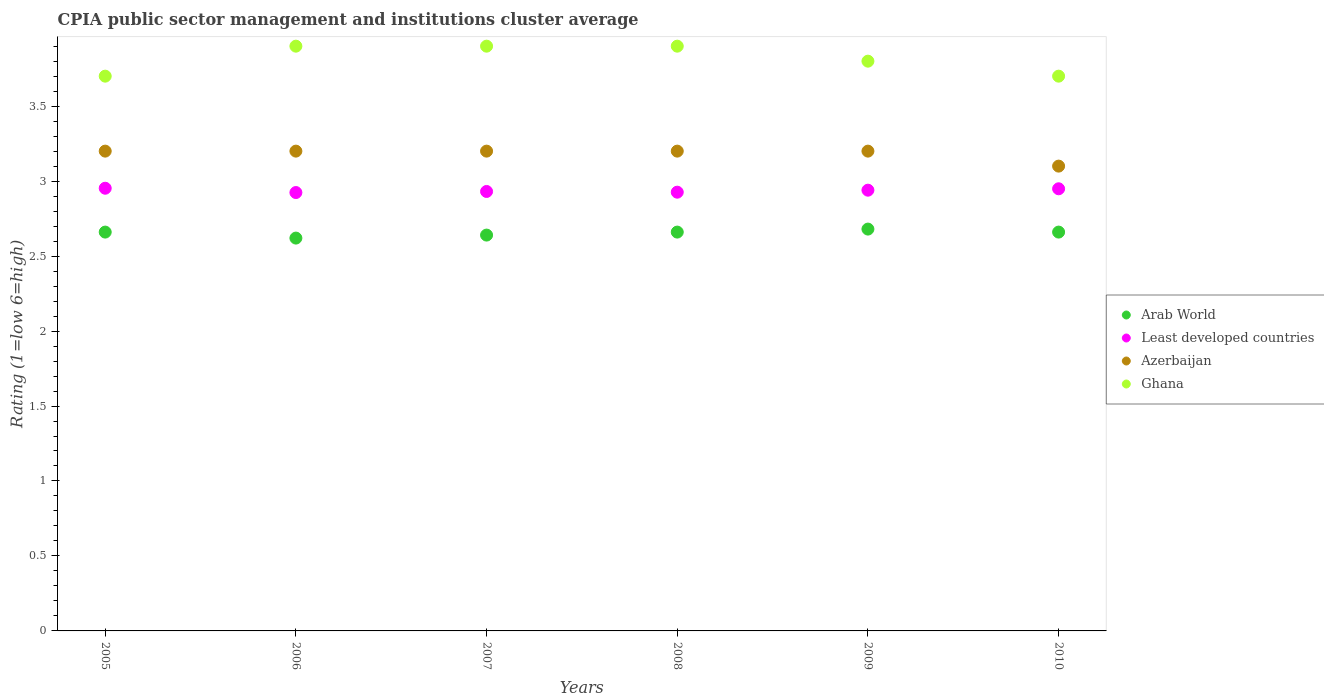How many different coloured dotlines are there?
Offer a terse response. 4. Across all years, what is the maximum CPIA rating in Azerbaijan?
Provide a short and direct response. 3.2. Across all years, what is the minimum CPIA rating in Azerbaijan?
Make the answer very short. 3.1. In which year was the CPIA rating in Least developed countries maximum?
Your answer should be very brief. 2005. In which year was the CPIA rating in Ghana minimum?
Offer a terse response. 2005. What is the difference between the CPIA rating in Least developed countries in 2005 and that in 2009?
Your answer should be compact. 0.01. What is the difference between the CPIA rating in Ghana in 2005 and the CPIA rating in Azerbaijan in 2009?
Keep it short and to the point. 0.5. What is the average CPIA rating in Arab World per year?
Your response must be concise. 2.65. In the year 2009, what is the difference between the CPIA rating in Arab World and CPIA rating in Least developed countries?
Your answer should be very brief. -0.26. What is the ratio of the CPIA rating in Arab World in 2006 to that in 2009?
Make the answer very short. 0.98. Is the difference between the CPIA rating in Arab World in 2005 and 2006 greater than the difference between the CPIA rating in Least developed countries in 2005 and 2006?
Make the answer very short. Yes. What is the difference between the highest and the second highest CPIA rating in Arab World?
Your answer should be very brief. 0.02. What is the difference between the highest and the lowest CPIA rating in Ghana?
Provide a succinct answer. 0.2. In how many years, is the CPIA rating in Arab World greater than the average CPIA rating in Arab World taken over all years?
Your answer should be very brief. 4. Is it the case that in every year, the sum of the CPIA rating in Ghana and CPIA rating in Azerbaijan  is greater than the sum of CPIA rating in Arab World and CPIA rating in Least developed countries?
Offer a very short reply. Yes. Is the CPIA rating in Least developed countries strictly greater than the CPIA rating in Arab World over the years?
Your answer should be very brief. Yes. Is the CPIA rating in Ghana strictly less than the CPIA rating in Arab World over the years?
Offer a very short reply. No. How many dotlines are there?
Provide a short and direct response. 4. How many years are there in the graph?
Give a very brief answer. 6. What is the difference between two consecutive major ticks on the Y-axis?
Offer a very short reply. 0.5. Does the graph contain any zero values?
Make the answer very short. No. Does the graph contain grids?
Provide a succinct answer. No. How many legend labels are there?
Offer a terse response. 4. How are the legend labels stacked?
Provide a short and direct response. Vertical. What is the title of the graph?
Ensure brevity in your answer.  CPIA public sector management and institutions cluster average. Does "Virgin Islands" appear as one of the legend labels in the graph?
Offer a very short reply. No. What is the label or title of the X-axis?
Keep it short and to the point. Years. What is the Rating (1=low 6=high) of Arab World in 2005?
Provide a short and direct response. 2.66. What is the Rating (1=low 6=high) in Least developed countries in 2005?
Your answer should be very brief. 2.95. What is the Rating (1=low 6=high) in Arab World in 2006?
Provide a succinct answer. 2.62. What is the Rating (1=low 6=high) in Least developed countries in 2006?
Give a very brief answer. 2.92. What is the Rating (1=low 6=high) in Arab World in 2007?
Your response must be concise. 2.64. What is the Rating (1=low 6=high) of Least developed countries in 2007?
Your answer should be compact. 2.93. What is the Rating (1=low 6=high) in Arab World in 2008?
Offer a very short reply. 2.66. What is the Rating (1=low 6=high) in Least developed countries in 2008?
Offer a very short reply. 2.93. What is the Rating (1=low 6=high) of Azerbaijan in 2008?
Offer a terse response. 3.2. What is the Rating (1=low 6=high) in Arab World in 2009?
Your response must be concise. 2.68. What is the Rating (1=low 6=high) of Least developed countries in 2009?
Make the answer very short. 2.94. What is the Rating (1=low 6=high) of Azerbaijan in 2009?
Keep it short and to the point. 3.2. What is the Rating (1=low 6=high) of Arab World in 2010?
Keep it short and to the point. 2.66. What is the Rating (1=low 6=high) of Least developed countries in 2010?
Provide a succinct answer. 2.95. What is the Rating (1=low 6=high) in Azerbaijan in 2010?
Offer a terse response. 3.1. Across all years, what is the maximum Rating (1=low 6=high) of Arab World?
Offer a terse response. 2.68. Across all years, what is the maximum Rating (1=low 6=high) of Least developed countries?
Your answer should be very brief. 2.95. Across all years, what is the maximum Rating (1=low 6=high) of Azerbaijan?
Ensure brevity in your answer.  3.2. Across all years, what is the minimum Rating (1=low 6=high) of Arab World?
Make the answer very short. 2.62. Across all years, what is the minimum Rating (1=low 6=high) of Least developed countries?
Provide a short and direct response. 2.92. Across all years, what is the minimum Rating (1=low 6=high) of Azerbaijan?
Offer a terse response. 3.1. What is the total Rating (1=low 6=high) in Arab World in the graph?
Ensure brevity in your answer.  15.92. What is the total Rating (1=low 6=high) of Least developed countries in the graph?
Your response must be concise. 17.62. What is the total Rating (1=low 6=high) of Ghana in the graph?
Keep it short and to the point. 22.9. What is the difference between the Rating (1=low 6=high) in Arab World in 2005 and that in 2006?
Your response must be concise. 0.04. What is the difference between the Rating (1=low 6=high) of Least developed countries in 2005 and that in 2006?
Provide a succinct answer. 0.03. What is the difference between the Rating (1=low 6=high) of Azerbaijan in 2005 and that in 2006?
Offer a terse response. 0. What is the difference between the Rating (1=low 6=high) in Ghana in 2005 and that in 2006?
Make the answer very short. -0.2. What is the difference between the Rating (1=low 6=high) of Least developed countries in 2005 and that in 2007?
Your answer should be very brief. 0.02. What is the difference between the Rating (1=low 6=high) in Azerbaijan in 2005 and that in 2007?
Provide a short and direct response. 0. What is the difference between the Rating (1=low 6=high) in Ghana in 2005 and that in 2007?
Your answer should be compact. -0.2. What is the difference between the Rating (1=low 6=high) of Arab World in 2005 and that in 2008?
Your answer should be very brief. 0. What is the difference between the Rating (1=low 6=high) in Least developed countries in 2005 and that in 2008?
Provide a succinct answer. 0.03. What is the difference between the Rating (1=low 6=high) of Arab World in 2005 and that in 2009?
Provide a succinct answer. -0.02. What is the difference between the Rating (1=low 6=high) of Least developed countries in 2005 and that in 2009?
Offer a terse response. 0.01. What is the difference between the Rating (1=low 6=high) in Azerbaijan in 2005 and that in 2009?
Offer a very short reply. 0. What is the difference between the Rating (1=low 6=high) of Least developed countries in 2005 and that in 2010?
Make the answer very short. 0. What is the difference between the Rating (1=low 6=high) in Arab World in 2006 and that in 2007?
Your answer should be compact. -0.02. What is the difference between the Rating (1=low 6=high) in Least developed countries in 2006 and that in 2007?
Offer a very short reply. -0.01. What is the difference between the Rating (1=low 6=high) in Azerbaijan in 2006 and that in 2007?
Provide a succinct answer. 0. What is the difference between the Rating (1=low 6=high) in Arab World in 2006 and that in 2008?
Provide a succinct answer. -0.04. What is the difference between the Rating (1=low 6=high) of Least developed countries in 2006 and that in 2008?
Your answer should be very brief. -0. What is the difference between the Rating (1=low 6=high) of Ghana in 2006 and that in 2008?
Offer a terse response. 0. What is the difference between the Rating (1=low 6=high) of Arab World in 2006 and that in 2009?
Offer a very short reply. -0.06. What is the difference between the Rating (1=low 6=high) in Least developed countries in 2006 and that in 2009?
Your answer should be very brief. -0.02. What is the difference between the Rating (1=low 6=high) in Azerbaijan in 2006 and that in 2009?
Provide a succinct answer. 0. What is the difference between the Rating (1=low 6=high) of Ghana in 2006 and that in 2009?
Give a very brief answer. 0.1. What is the difference between the Rating (1=low 6=high) of Arab World in 2006 and that in 2010?
Provide a succinct answer. -0.04. What is the difference between the Rating (1=low 6=high) of Least developed countries in 2006 and that in 2010?
Your response must be concise. -0.03. What is the difference between the Rating (1=low 6=high) in Azerbaijan in 2006 and that in 2010?
Give a very brief answer. 0.1. What is the difference between the Rating (1=low 6=high) in Ghana in 2006 and that in 2010?
Offer a very short reply. 0.2. What is the difference between the Rating (1=low 6=high) of Arab World in 2007 and that in 2008?
Give a very brief answer. -0.02. What is the difference between the Rating (1=low 6=high) in Least developed countries in 2007 and that in 2008?
Provide a short and direct response. 0. What is the difference between the Rating (1=low 6=high) of Azerbaijan in 2007 and that in 2008?
Offer a terse response. 0. What is the difference between the Rating (1=low 6=high) of Ghana in 2007 and that in 2008?
Provide a short and direct response. 0. What is the difference between the Rating (1=low 6=high) in Arab World in 2007 and that in 2009?
Offer a terse response. -0.04. What is the difference between the Rating (1=low 6=high) in Least developed countries in 2007 and that in 2009?
Offer a very short reply. -0.01. What is the difference between the Rating (1=low 6=high) in Ghana in 2007 and that in 2009?
Provide a short and direct response. 0.1. What is the difference between the Rating (1=low 6=high) in Arab World in 2007 and that in 2010?
Offer a very short reply. -0.02. What is the difference between the Rating (1=low 6=high) of Least developed countries in 2007 and that in 2010?
Give a very brief answer. -0.02. What is the difference between the Rating (1=low 6=high) in Azerbaijan in 2007 and that in 2010?
Offer a very short reply. 0.1. What is the difference between the Rating (1=low 6=high) in Arab World in 2008 and that in 2009?
Keep it short and to the point. -0.02. What is the difference between the Rating (1=low 6=high) of Least developed countries in 2008 and that in 2009?
Provide a short and direct response. -0.01. What is the difference between the Rating (1=low 6=high) of Azerbaijan in 2008 and that in 2009?
Your answer should be very brief. 0. What is the difference between the Rating (1=low 6=high) in Arab World in 2008 and that in 2010?
Give a very brief answer. 0. What is the difference between the Rating (1=low 6=high) in Least developed countries in 2008 and that in 2010?
Your answer should be very brief. -0.02. What is the difference between the Rating (1=low 6=high) of Azerbaijan in 2008 and that in 2010?
Offer a very short reply. 0.1. What is the difference between the Rating (1=low 6=high) in Ghana in 2008 and that in 2010?
Ensure brevity in your answer.  0.2. What is the difference between the Rating (1=low 6=high) of Arab World in 2009 and that in 2010?
Offer a terse response. 0.02. What is the difference between the Rating (1=low 6=high) of Least developed countries in 2009 and that in 2010?
Your answer should be very brief. -0.01. What is the difference between the Rating (1=low 6=high) in Azerbaijan in 2009 and that in 2010?
Provide a succinct answer. 0.1. What is the difference between the Rating (1=low 6=high) in Ghana in 2009 and that in 2010?
Offer a terse response. 0.1. What is the difference between the Rating (1=low 6=high) in Arab World in 2005 and the Rating (1=low 6=high) in Least developed countries in 2006?
Your answer should be very brief. -0.26. What is the difference between the Rating (1=low 6=high) in Arab World in 2005 and the Rating (1=low 6=high) in Azerbaijan in 2006?
Your answer should be compact. -0.54. What is the difference between the Rating (1=low 6=high) of Arab World in 2005 and the Rating (1=low 6=high) of Ghana in 2006?
Give a very brief answer. -1.24. What is the difference between the Rating (1=low 6=high) in Least developed countries in 2005 and the Rating (1=low 6=high) in Azerbaijan in 2006?
Ensure brevity in your answer.  -0.25. What is the difference between the Rating (1=low 6=high) of Least developed countries in 2005 and the Rating (1=low 6=high) of Ghana in 2006?
Provide a succinct answer. -0.95. What is the difference between the Rating (1=low 6=high) of Arab World in 2005 and the Rating (1=low 6=high) of Least developed countries in 2007?
Keep it short and to the point. -0.27. What is the difference between the Rating (1=low 6=high) of Arab World in 2005 and the Rating (1=low 6=high) of Azerbaijan in 2007?
Make the answer very short. -0.54. What is the difference between the Rating (1=low 6=high) of Arab World in 2005 and the Rating (1=low 6=high) of Ghana in 2007?
Offer a terse response. -1.24. What is the difference between the Rating (1=low 6=high) in Least developed countries in 2005 and the Rating (1=low 6=high) in Azerbaijan in 2007?
Give a very brief answer. -0.25. What is the difference between the Rating (1=low 6=high) in Least developed countries in 2005 and the Rating (1=low 6=high) in Ghana in 2007?
Ensure brevity in your answer.  -0.95. What is the difference between the Rating (1=low 6=high) of Arab World in 2005 and the Rating (1=low 6=high) of Least developed countries in 2008?
Your answer should be very brief. -0.27. What is the difference between the Rating (1=low 6=high) in Arab World in 2005 and the Rating (1=low 6=high) in Azerbaijan in 2008?
Make the answer very short. -0.54. What is the difference between the Rating (1=low 6=high) in Arab World in 2005 and the Rating (1=low 6=high) in Ghana in 2008?
Offer a terse response. -1.24. What is the difference between the Rating (1=low 6=high) of Least developed countries in 2005 and the Rating (1=low 6=high) of Azerbaijan in 2008?
Offer a terse response. -0.25. What is the difference between the Rating (1=low 6=high) of Least developed countries in 2005 and the Rating (1=low 6=high) of Ghana in 2008?
Ensure brevity in your answer.  -0.95. What is the difference between the Rating (1=low 6=high) in Arab World in 2005 and the Rating (1=low 6=high) in Least developed countries in 2009?
Provide a short and direct response. -0.28. What is the difference between the Rating (1=low 6=high) in Arab World in 2005 and the Rating (1=low 6=high) in Azerbaijan in 2009?
Give a very brief answer. -0.54. What is the difference between the Rating (1=low 6=high) in Arab World in 2005 and the Rating (1=low 6=high) in Ghana in 2009?
Your response must be concise. -1.14. What is the difference between the Rating (1=low 6=high) of Least developed countries in 2005 and the Rating (1=low 6=high) of Azerbaijan in 2009?
Offer a very short reply. -0.25. What is the difference between the Rating (1=low 6=high) of Least developed countries in 2005 and the Rating (1=low 6=high) of Ghana in 2009?
Make the answer very short. -0.85. What is the difference between the Rating (1=low 6=high) in Arab World in 2005 and the Rating (1=low 6=high) in Least developed countries in 2010?
Provide a succinct answer. -0.29. What is the difference between the Rating (1=low 6=high) in Arab World in 2005 and the Rating (1=low 6=high) in Azerbaijan in 2010?
Provide a succinct answer. -0.44. What is the difference between the Rating (1=low 6=high) of Arab World in 2005 and the Rating (1=low 6=high) of Ghana in 2010?
Make the answer very short. -1.04. What is the difference between the Rating (1=low 6=high) in Least developed countries in 2005 and the Rating (1=low 6=high) in Azerbaijan in 2010?
Offer a terse response. -0.15. What is the difference between the Rating (1=low 6=high) in Least developed countries in 2005 and the Rating (1=low 6=high) in Ghana in 2010?
Keep it short and to the point. -0.75. What is the difference between the Rating (1=low 6=high) of Arab World in 2006 and the Rating (1=low 6=high) of Least developed countries in 2007?
Give a very brief answer. -0.31. What is the difference between the Rating (1=low 6=high) in Arab World in 2006 and the Rating (1=low 6=high) in Azerbaijan in 2007?
Your answer should be compact. -0.58. What is the difference between the Rating (1=low 6=high) of Arab World in 2006 and the Rating (1=low 6=high) of Ghana in 2007?
Ensure brevity in your answer.  -1.28. What is the difference between the Rating (1=low 6=high) of Least developed countries in 2006 and the Rating (1=low 6=high) of Azerbaijan in 2007?
Your answer should be compact. -0.28. What is the difference between the Rating (1=low 6=high) of Least developed countries in 2006 and the Rating (1=low 6=high) of Ghana in 2007?
Your answer should be compact. -0.98. What is the difference between the Rating (1=low 6=high) in Azerbaijan in 2006 and the Rating (1=low 6=high) in Ghana in 2007?
Keep it short and to the point. -0.7. What is the difference between the Rating (1=low 6=high) in Arab World in 2006 and the Rating (1=low 6=high) in Least developed countries in 2008?
Give a very brief answer. -0.31. What is the difference between the Rating (1=low 6=high) of Arab World in 2006 and the Rating (1=low 6=high) of Azerbaijan in 2008?
Offer a very short reply. -0.58. What is the difference between the Rating (1=low 6=high) in Arab World in 2006 and the Rating (1=low 6=high) in Ghana in 2008?
Make the answer very short. -1.28. What is the difference between the Rating (1=low 6=high) in Least developed countries in 2006 and the Rating (1=low 6=high) in Azerbaijan in 2008?
Your answer should be compact. -0.28. What is the difference between the Rating (1=low 6=high) of Least developed countries in 2006 and the Rating (1=low 6=high) of Ghana in 2008?
Ensure brevity in your answer.  -0.98. What is the difference between the Rating (1=low 6=high) in Azerbaijan in 2006 and the Rating (1=low 6=high) in Ghana in 2008?
Offer a terse response. -0.7. What is the difference between the Rating (1=low 6=high) in Arab World in 2006 and the Rating (1=low 6=high) in Least developed countries in 2009?
Ensure brevity in your answer.  -0.32. What is the difference between the Rating (1=low 6=high) of Arab World in 2006 and the Rating (1=low 6=high) of Azerbaijan in 2009?
Keep it short and to the point. -0.58. What is the difference between the Rating (1=low 6=high) of Arab World in 2006 and the Rating (1=low 6=high) of Ghana in 2009?
Ensure brevity in your answer.  -1.18. What is the difference between the Rating (1=low 6=high) in Least developed countries in 2006 and the Rating (1=low 6=high) in Azerbaijan in 2009?
Your answer should be compact. -0.28. What is the difference between the Rating (1=low 6=high) in Least developed countries in 2006 and the Rating (1=low 6=high) in Ghana in 2009?
Your answer should be very brief. -0.88. What is the difference between the Rating (1=low 6=high) of Arab World in 2006 and the Rating (1=low 6=high) of Least developed countries in 2010?
Ensure brevity in your answer.  -0.33. What is the difference between the Rating (1=low 6=high) of Arab World in 2006 and the Rating (1=low 6=high) of Azerbaijan in 2010?
Your response must be concise. -0.48. What is the difference between the Rating (1=low 6=high) in Arab World in 2006 and the Rating (1=low 6=high) in Ghana in 2010?
Ensure brevity in your answer.  -1.08. What is the difference between the Rating (1=low 6=high) in Least developed countries in 2006 and the Rating (1=low 6=high) in Azerbaijan in 2010?
Offer a very short reply. -0.18. What is the difference between the Rating (1=low 6=high) of Least developed countries in 2006 and the Rating (1=low 6=high) of Ghana in 2010?
Make the answer very short. -0.78. What is the difference between the Rating (1=low 6=high) in Arab World in 2007 and the Rating (1=low 6=high) in Least developed countries in 2008?
Provide a short and direct response. -0.29. What is the difference between the Rating (1=low 6=high) of Arab World in 2007 and the Rating (1=low 6=high) of Azerbaijan in 2008?
Keep it short and to the point. -0.56. What is the difference between the Rating (1=low 6=high) in Arab World in 2007 and the Rating (1=low 6=high) in Ghana in 2008?
Your answer should be very brief. -1.26. What is the difference between the Rating (1=low 6=high) in Least developed countries in 2007 and the Rating (1=low 6=high) in Azerbaijan in 2008?
Your answer should be compact. -0.27. What is the difference between the Rating (1=low 6=high) of Least developed countries in 2007 and the Rating (1=low 6=high) of Ghana in 2008?
Make the answer very short. -0.97. What is the difference between the Rating (1=low 6=high) in Arab World in 2007 and the Rating (1=low 6=high) in Least developed countries in 2009?
Offer a very short reply. -0.3. What is the difference between the Rating (1=low 6=high) in Arab World in 2007 and the Rating (1=low 6=high) in Azerbaijan in 2009?
Offer a terse response. -0.56. What is the difference between the Rating (1=low 6=high) in Arab World in 2007 and the Rating (1=low 6=high) in Ghana in 2009?
Your response must be concise. -1.16. What is the difference between the Rating (1=low 6=high) in Least developed countries in 2007 and the Rating (1=low 6=high) in Azerbaijan in 2009?
Give a very brief answer. -0.27. What is the difference between the Rating (1=low 6=high) in Least developed countries in 2007 and the Rating (1=low 6=high) in Ghana in 2009?
Offer a very short reply. -0.87. What is the difference between the Rating (1=low 6=high) of Arab World in 2007 and the Rating (1=low 6=high) of Least developed countries in 2010?
Offer a very short reply. -0.31. What is the difference between the Rating (1=low 6=high) in Arab World in 2007 and the Rating (1=low 6=high) in Azerbaijan in 2010?
Offer a terse response. -0.46. What is the difference between the Rating (1=low 6=high) of Arab World in 2007 and the Rating (1=low 6=high) of Ghana in 2010?
Make the answer very short. -1.06. What is the difference between the Rating (1=low 6=high) in Least developed countries in 2007 and the Rating (1=low 6=high) in Azerbaijan in 2010?
Your answer should be very brief. -0.17. What is the difference between the Rating (1=low 6=high) in Least developed countries in 2007 and the Rating (1=low 6=high) in Ghana in 2010?
Make the answer very short. -0.77. What is the difference between the Rating (1=low 6=high) in Arab World in 2008 and the Rating (1=low 6=high) in Least developed countries in 2009?
Your answer should be very brief. -0.28. What is the difference between the Rating (1=low 6=high) of Arab World in 2008 and the Rating (1=low 6=high) of Azerbaijan in 2009?
Offer a very short reply. -0.54. What is the difference between the Rating (1=low 6=high) of Arab World in 2008 and the Rating (1=low 6=high) of Ghana in 2009?
Make the answer very short. -1.14. What is the difference between the Rating (1=low 6=high) in Least developed countries in 2008 and the Rating (1=low 6=high) in Azerbaijan in 2009?
Keep it short and to the point. -0.27. What is the difference between the Rating (1=low 6=high) of Least developed countries in 2008 and the Rating (1=low 6=high) of Ghana in 2009?
Keep it short and to the point. -0.87. What is the difference between the Rating (1=low 6=high) in Arab World in 2008 and the Rating (1=low 6=high) in Least developed countries in 2010?
Ensure brevity in your answer.  -0.29. What is the difference between the Rating (1=low 6=high) in Arab World in 2008 and the Rating (1=low 6=high) in Azerbaijan in 2010?
Your answer should be very brief. -0.44. What is the difference between the Rating (1=low 6=high) in Arab World in 2008 and the Rating (1=low 6=high) in Ghana in 2010?
Your response must be concise. -1.04. What is the difference between the Rating (1=low 6=high) in Least developed countries in 2008 and the Rating (1=low 6=high) in Azerbaijan in 2010?
Offer a very short reply. -0.17. What is the difference between the Rating (1=low 6=high) in Least developed countries in 2008 and the Rating (1=low 6=high) in Ghana in 2010?
Offer a very short reply. -0.77. What is the difference between the Rating (1=low 6=high) in Arab World in 2009 and the Rating (1=low 6=high) in Least developed countries in 2010?
Your answer should be compact. -0.27. What is the difference between the Rating (1=low 6=high) in Arab World in 2009 and the Rating (1=low 6=high) in Azerbaijan in 2010?
Offer a very short reply. -0.42. What is the difference between the Rating (1=low 6=high) of Arab World in 2009 and the Rating (1=low 6=high) of Ghana in 2010?
Provide a succinct answer. -1.02. What is the difference between the Rating (1=low 6=high) in Least developed countries in 2009 and the Rating (1=low 6=high) in Azerbaijan in 2010?
Offer a terse response. -0.16. What is the difference between the Rating (1=low 6=high) of Least developed countries in 2009 and the Rating (1=low 6=high) of Ghana in 2010?
Make the answer very short. -0.76. What is the difference between the Rating (1=low 6=high) in Azerbaijan in 2009 and the Rating (1=low 6=high) in Ghana in 2010?
Your answer should be compact. -0.5. What is the average Rating (1=low 6=high) of Arab World per year?
Offer a very short reply. 2.65. What is the average Rating (1=low 6=high) of Least developed countries per year?
Ensure brevity in your answer.  2.94. What is the average Rating (1=low 6=high) of Azerbaijan per year?
Make the answer very short. 3.18. What is the average Rating (1=low 6=high) of Ghana per year?
Keep it short and to the point. 3.82. In the year 2005, what is the difference between the Rating (1=low 6=high) of Arab World and Rating (1=low 6=high) of Least developed countries?
Make the answer very short. -0.29. In the year 2005, what is the difference between the Rating (1=low 6=high) of Arab World and Rating (1=low 6=high) of Azerbaijan?
Offer a very short reply. -0.54. In the year 2005, what is the difference between the Rating (1=low 6=high) in Arab World and Rating (1=low 6=high) in Ghana?
Your answer should be very brief. -1.04. In the year 2005, what is the difference between the Rating (1=low 6=high) in Least developed countries and Rating (1=low 6=high) in Azerbaijan?
Keep it short and to the point. -0.25. In the year 2005, what is the difference between the Rating (1=low 6=high) in Least developed countries and Rating (1=low 6=high) in Ghana?
Ensure brevity in your answer.  -0.75. In the year 2006, what is the difference between the Rating (1=low 6=high) in Arab World and Rating (1=low 6=high) in Least developed countries?
Your answer should be very brief. -0.3. In the year 2006, what is the difference between the Rating (1=low 6=high) of Arab World and Rating (1=low 6=high) of Azerbaijan?
Make the answer very short. -0.58. In the year 2006, what is the difference between the Rating (1=low 6=high) in Arab World and Rating (1=low 6=high) in Ghana?
Offer a very short reply. -1.28. In the year 2006, what is the difference between the Rating (1=low 6=high) in Least developed countries and Rating (1=low 6=high) in Azerbaijan?
Make the answer very short. -0.28. In the year 2006, what is the difference between the Rating (1=low 6=high) of Least developed countries and Rating (1=low 6=high) of Ghana?
Offer a terse response. -0.98. In the year 2006, what is the difference between the Rating (1=low 6=high) of Azerbaijan and Rating (1=low 6=high) of Ghana?
Your answer should be very brief. -0.7. In the year 2007, what is the difference between the Rating (1=low 6=high) in Arab World and Rating (1=low 6=high) in Least developed countries?
Offer a terse response. -0.29. In the year 2007, what is the difference between the Rating (1=low 6=high) of Arab World and Rating (1=low 6=high) of Azerbaijan?
Give a very brief answer. -0.56. In the year 2007, what is the difference between the Rating (1=low 6=high) of Arab World and Rating (1=low 6=high) of Ghana?
Provide a succinct answer. -1.26. In the year 2007, what is the difference between the Rating (1=low 6=high) of Least developed countries and Rating (1=low 6=high) of Azerbaijan?
Keep it short and to the point. -0.27. In the year 2007, what is the difference between the Rating (1=low 6=high) of Least developed countries and Rating (1=low 6=high) of Ghana?
Provide a succinct answer. -0.97. In the year 2007, what is the difference between the Rating (1=low 6=high) of Azerbaijan and Rating (1=low 6=high) of Ghana?
Your response must be concise. -0.7. In the year 2008, what is the difference between the Rating (1=low 6=high) of Arab World and Rating (1=low 6=high) of Least developed countries?
Ensure brevity in your answer.  -0.27. In the year 2008, what is the difference between the Rating (1=low 6=high) of Arab World and Rating (1=low 6=high) of Azerbaijan?
Offer a terse response. -0.54. In the year 2008, what is the difference between the Rating (1=low 6=high) of Arab World and Rating (1=low 6=high) of Ghana?
Your response must be concise. -1.24. In the year 2008, what is the difference between the Rating (1=low 6=high) in Least developed countries and Rating (1=low 6=high) in Azerbaijan?
Keep it short and to the point. -0.27. In the year 2008, what is the difference between the Rating (1=low 6=high) in Least developed countries and Rating (1=low 6=high) in Ghana?
Ensure brevity in your answer.  -0.97. In the year 2008, what is the difference between the Rating (1=low 6=high) of Azerbaijan and Rating (1=low 6=high) of Ghana?
Your answer should be very brief. -0.7. In the year 2009, what is the difference between the Rating (1=low 6=high) in Arab World and Rating (1=low 6=high) in Least developed countries?
Make the answer very short. -0.26. In the year 2009, what is the difference between the Rating (1=low 6=high) of Arab World and Rating (1=low 6=high) of Azerbaijan?
Provide a succinct answer. -0.52. In the year 2009, what is the difference between the Rating (1=low 6=high) in Arab World and Rating (1=low 6=high) in Ghana?
Offer a very short reply. -1.12. In the year 2009, what is the difference between the Rating (1=low 6=high) in Least developed countries and Rating (1=low 6=high) in Azerbaijan?
Your response must be concise. -0.26. In the year 2009, what is the difference between the Rating (1=low 6=high) of Least developed countries and Rating (1=low 6=high) of Ghana?
Your response must be concise. -0.86. In the year 2010, what is the difference between the Rating (1=low 6=high) of Arab World and Rating (1=low 6=high) of Least developed countries?
Keep it short and to the point. -0.29. In the year 2010, what is the difference between the Rating (1=low 6=high) in Arab World and Rating (1=low 6=high) in Azerbaijan?
Offer a very short reply. -0.44. In the year 2010, what is the difference between the Rating (1=low 6=high) of Arab World and Rating (1=low 6=high) of Ghana?
Provide a succinct answer. -1.04. In the year 2010, what is the difference between the Rating (1=low 6=high) in Least developed countries and Rating (1=low 6=high) in Azerbaijan?
Your answer should be very brief. -0.15. In the year 2010, what is the difference between the Rating (1=low 6=high) in Least developed countries and Rating (1=low 6=high) in Ghana?
Your answer should be very brief. -0.75. In the year 2010, what is the difference between the Rating (1=low 6=high) in Azerbaijan and Rating (1=low 6=high) in Ghana?
Your answer should be very brief. -0.6. What is the ratio of the Rating (1=low 6=high) of Arab World in 2005 to that in 2006?
Give a very brief answer. 1.02. What is the ratio of the Rating (1=low 6=high) in Least developed countries in 2005 to that in 2006?
Provide a short and direct response. 1.01. What is the ratio of the Rating (1=low 6=high) in Azerbaijan in 2005 to that in 2006?
Make the answer very short. 1. What is the ratio of the Rating (1=low 6=high) of Ghana in 2005 to that in 2006?
Make the answer very short. 0.95. What is the ratio of the Rating (1=low 6=high) in Arab World in 2005 to that in 2007?
Offer a terse response. 1.01. What is the ratio of the Rating (1=low 6=high) in Least developed countries in 2005 to that in 2007?
Make the answer very short. 1.01. What is the ratio of the Rating (1=low 6=high) in Ghana in 2005 to that in 2007?
Your response must be concise. 0.95. What is the ratio of the Rating (1=low 6=high) in Least developed countries in 2005 to that in 2008?
Offer a terse response. 1.01. What is the ratio of the Rating (1=low 6=high) of Azerbaijan in 2005 to that in 2008?
Offer a very short reply. 1. What is the ratio of the Rating (1=low 6=high) in Ghana in 2005 to that in 2008?
Your response must be concise. 0.95. What is the ratio of the Rating (1=low 6=high) in Azerbaijan in 2005 to that in 2009?
Your answer should be very brief. 1. What is the ratio of the Rating (1=low 6=high) in Ghana in 2005 to that in 2009?
Offer a terse response. 0.97. What is the ratio of the Rating (1=low 6=high) of Azerbaijan in 2005 to that in 2010?
Offer a terse response. 1.03. What is the ratio of the Rating (1=low 6=high) in Ghana in 2005 to that in 2010?
Your answer should be compact. 1. What is the ratio of the Rating (1=low 6=high) of Least developed countries in 2006 to that in 2007?
Keep it short and to the point. 1. What is the ratio of the Rating (1=low 6=high) in Ghana in 2006 to that in 2007?
Make the answer very short. 1. What is the ratio of the Rating (1=low 6=high) in Ghana in 2006 to that in 2008?
Make the answer very short. 1. What is the ratio of the Rating (1=low 6=high) of Arab World in 2006 to that in 2009?
Make the answer very short. 0.98. What is the ratio of the Rating (1=low 6=high) of Ghana in 2006 to that in 2009?
Offer a terse response. 1.03. What is the ratio of the Rating (1=low 6=high) in Azerbaijan in 2006 to that in 2010?
Your response must be concise. 1.03. What is the ratio of the Rating (1=low 6=high) in Ghana in 2006 to that in 2010?
Your answer should be very brief. 1.05. What is the ratio of the Rating (1=low 6=high) in Arab World in 2007 to that in 2008?
Give a very brief answer. 0.99. What is the ratio of the Rating (1=low 6=high) in Least developed countries in 2007 to that in 2008?
Make the answer very short. 1. What is the ratio of the Rating (1=low 6=high) of Arab World in 2007 to that in 2009?
Keep it short and to the point. 0.99. What is the ratio of the Rating (1=low 6=high) of Least developed countries in 2007 to that in 2009?
Give a very brief answer. 1. What is the ratio of the Rating (1=low 6=high) in Ghana in 2007 to that in 2009?
Offer a terse response. 1.03. What is the ratio of the Rating (1=low 6=high) in Azerbaijan in 2007 to that in 2010?
Provide a short and direct response. 1.03. What is the ratio of the Rating (1=low 6=high) in Ghana in 2007 to that in 2010?
Provide a short and direct response. 1.05. What is the ratio of the Rating (1=low 6=high) in Arab World in 2008 to that in 2009?
Ensure brevity in your answer.  0.99. What is the ratio of the Rating (1=low 6=high) in Azerbaijan in 2008 to that in 2009?
Give a very brief answer. 1. What is the ratio of the Rating (1=low 6=high) in Ghana in 2008 to that in 2009?
Provide a short and direct response. 1.03. What is the ratio of the Rating (1=low 6=high) of Arab World in 2008 to that in 2010?
Your answer should be very brief. 1. What is the ratio of the Rating (1=low 6=high) of Least developed countries in 2008 to that in 2010?
Your response must be concise. 0.99. What is the ratio of the Rating (1=low 6=high) of Azerbaijan in 2008 to that in 2010?
Offer a very short reply. 1.03. What is the ratio of the Rating (1=low 6=high) of Ghana in 2008 to that in 2010?
Keep it short and to the point. 1.05. What is the ratio of the Rating (1=low 6=high) in Arab World in 2009 to that in 2010?
Your answer should be very brief. 1.01. What is the ratio of the Rating (1=low 6=high) of Azerbaijan in 2009 to that in 2010?
Provide a short and direct response. 1.03. What is the ratio of the Rating (1=low 6=high) of Ghana in 2009 to that in 2010?
Provide a short and direct response. 1.03. What is the difference between the highest and the second highest Rating (1=low 6=high) in Least developed countries?
Your answer should be compact. 0. What is the difference between the highest and the second highest Rating (1=low 6=high) of Azerbaijan?
Provide a short and direct response. 0. What is the difference between the highest and the lowest Rating (1=low 6=high) in Arab World?
Your answer should be very brief. 0.06. What is the difference between the highest and the lowest Rating (1=low 6=high) of Least developed countries?
Your answer should be compact. 0.03. 